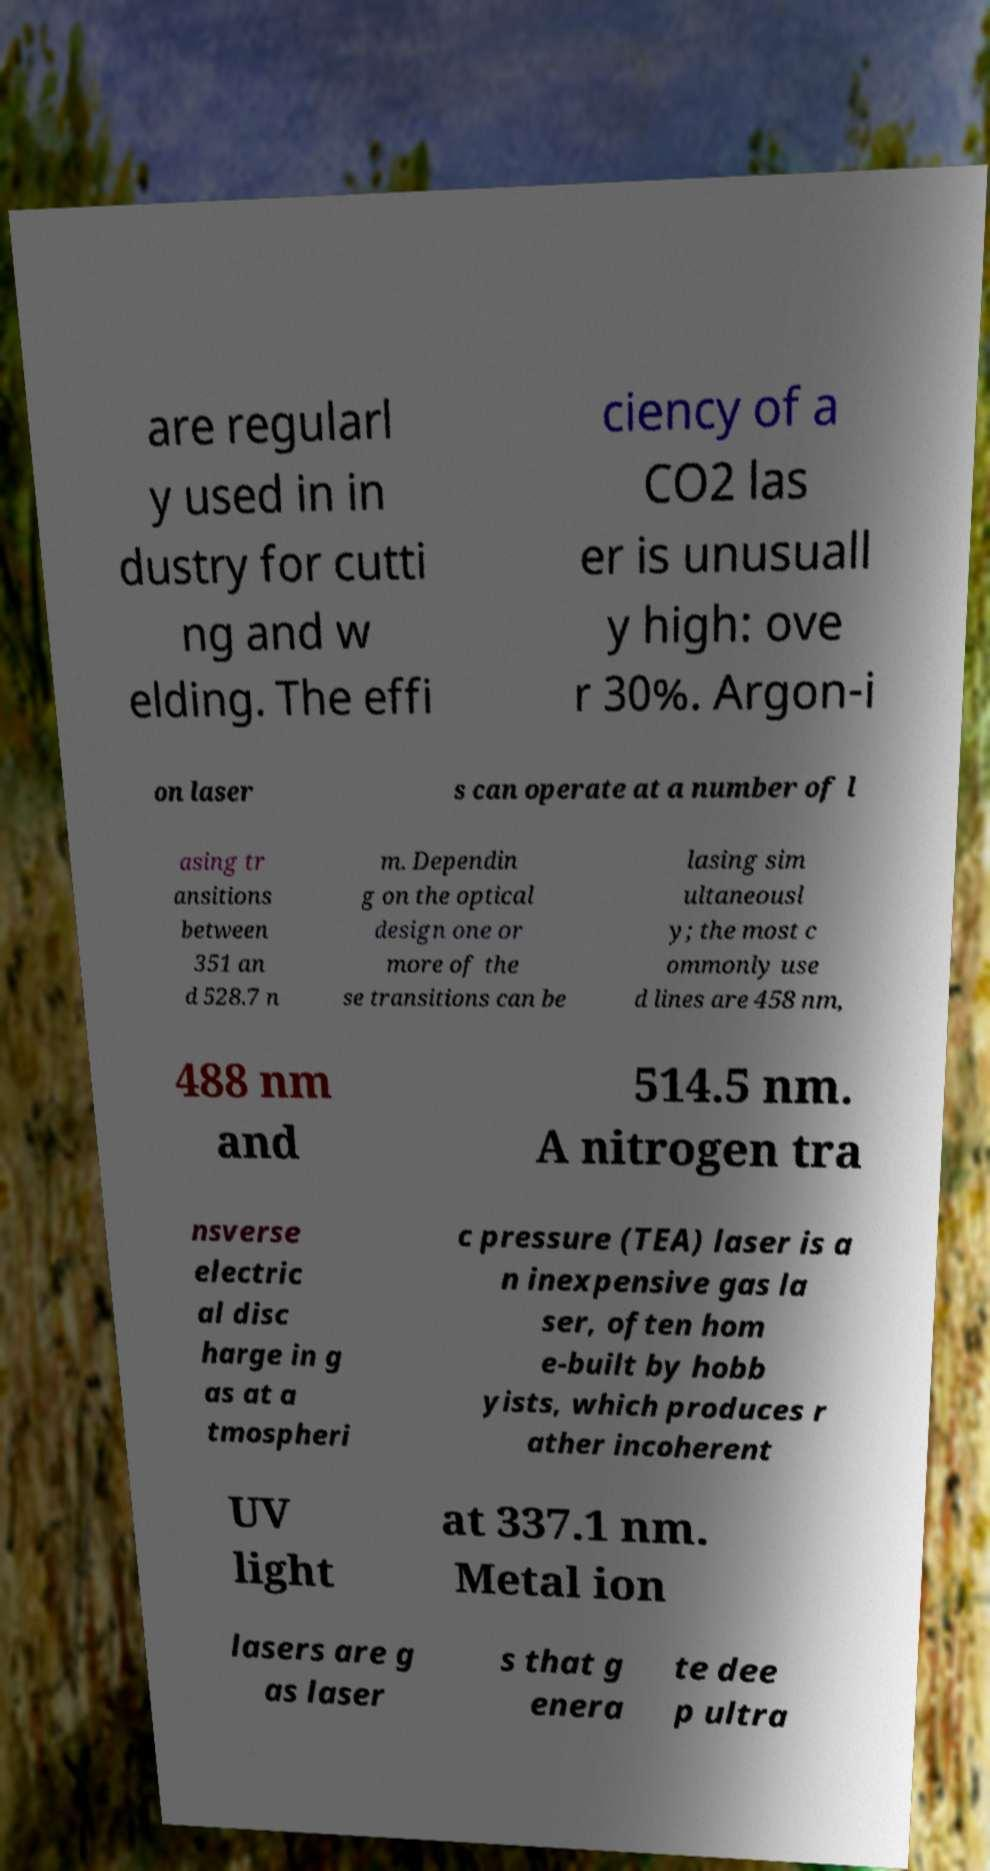Could you extract and type out the text from this image? are regularl y used in in dustry for cutti ng and w elding. The effi ciency of a CO2 las er is unusuall y high: ove r 30%. Argon-i on laser s can operate at a number of l asing tr ansitions between 351 an d 528.7 n m. Dependin g on the optical design one or more of the se transitions can be lasing sim ultaneousl y; the most c ommonly use d lines are 458 nm, 488 nm and 514.5 nm. A nitrogen tra nsverse electric al disc harge in g as at a tmospheri c pressure (TEA) laser is a n inexpensive gas la ser, often hom e-built by hobb yists, which produces r ather incoherent UV light at 337.1 nm. Metal ion lasers are g as laser s that g enera te dee p ultra 